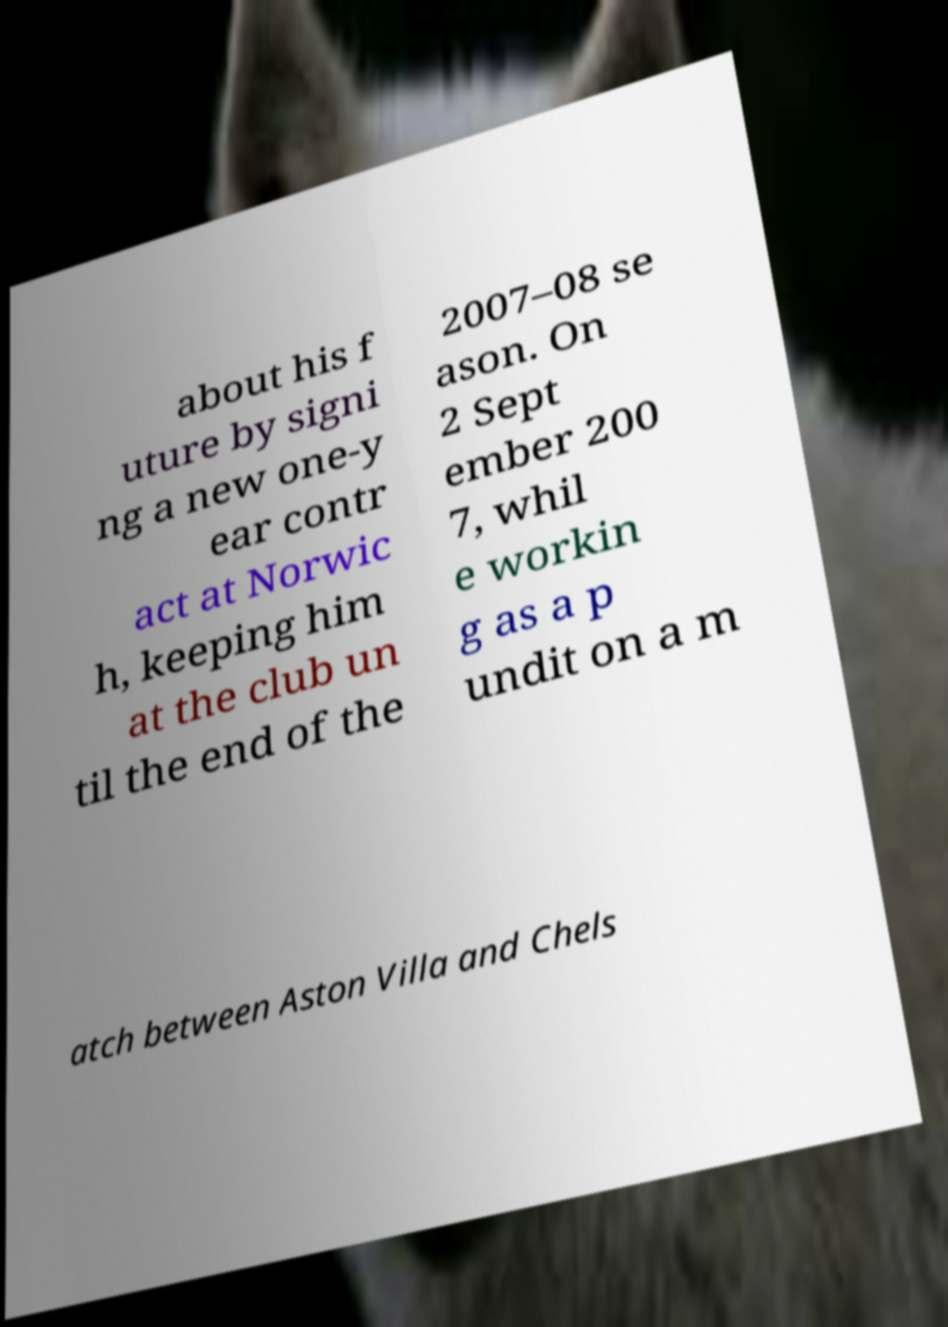Can you read and provide the text displayed in the image?This photo seems to have some interesting text. Can you extract and type it out for me? about his f uture by signi ng a new one-y ear contr act at Norwic h, keeping him at the club un til the end of the 2007–08 se ason. On 2 Sept ember 200 7, whil e workin g as a p undit on a m atch between Aston Villa and Chels 